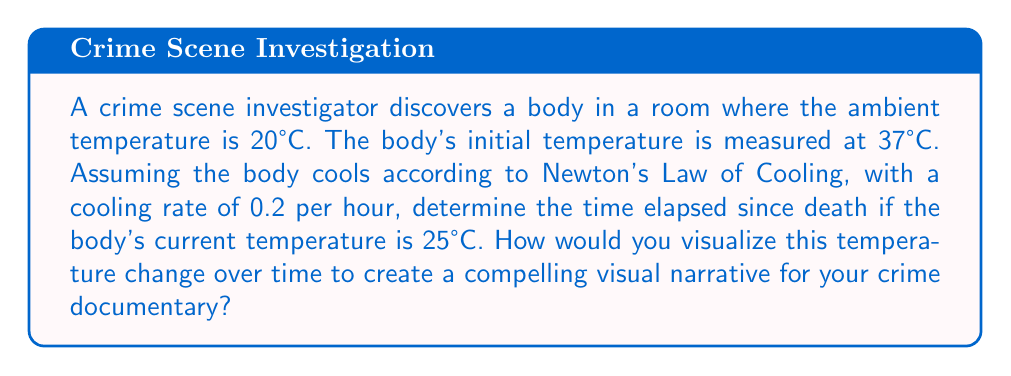Show me your answer to this math problem. To solve this problem and create a visual narrative, we'll use Newton's Law of Cooling and then discuss how to represent it visually.

1) Newton's Law of Cooling is given by the differential equation:

   $$\frac{dT}{dt} = -k(T - T_a)$$

   where $T$ is the temperature of the body, $T_a$ is the ambient temperature, $t$ is time, and $k$ is the cooling rate.

2) The solution to this equation is:

   $$T(t) = T_a + (T_0 - T_a)e^{-kt}$$

   where $T_0$ is the initial temperature of the body.

3) Given:
   - $T_a = 20°C$ (ambient temperature)
   - $T_0 = 37°C$ (initial body temperature)
   - $k = 0.2$ per hour (cooling rate)
   - $T(t) = 25°C$ (current body temperature)

4) Substituting these values into the equation:

   $$25 = 20 + (37 - 20)e^{-0.2t}$$

5) Simplifying:

   $$5 = 17e^{-0.2t}$$

6) Taking natural log of both sides:

   $$\ln(\frac{5}{17}) = -0.2t$$

7) Solving for $t$:

   $$t = -\frac{\ln(\frac{5}{17})}{0.2} \approx 6.18$$

To visualize this for a documentary:

1) Create a graph with time (hours) on the x-axis and temperature (°C) on the y-axis.
2) Plot the curve $T(t) = 20 + 17e^{-0.2t}$ from $t=0$ to $t=10$.
3) Highlight the point (6.18, 25) on the curve.
4) Use color gradients to represent temperature changes, with red for higher temperatures fading to blue for lower temperatures.
5) Animate the cooling process, showing how the body temperature changes over time.
6) Include a timeline that correlates with key events in the investigation.

This visual representation will help viewers understand the cooling process and its implications for determining the time of death.
Answer: 6.18 hours since death 